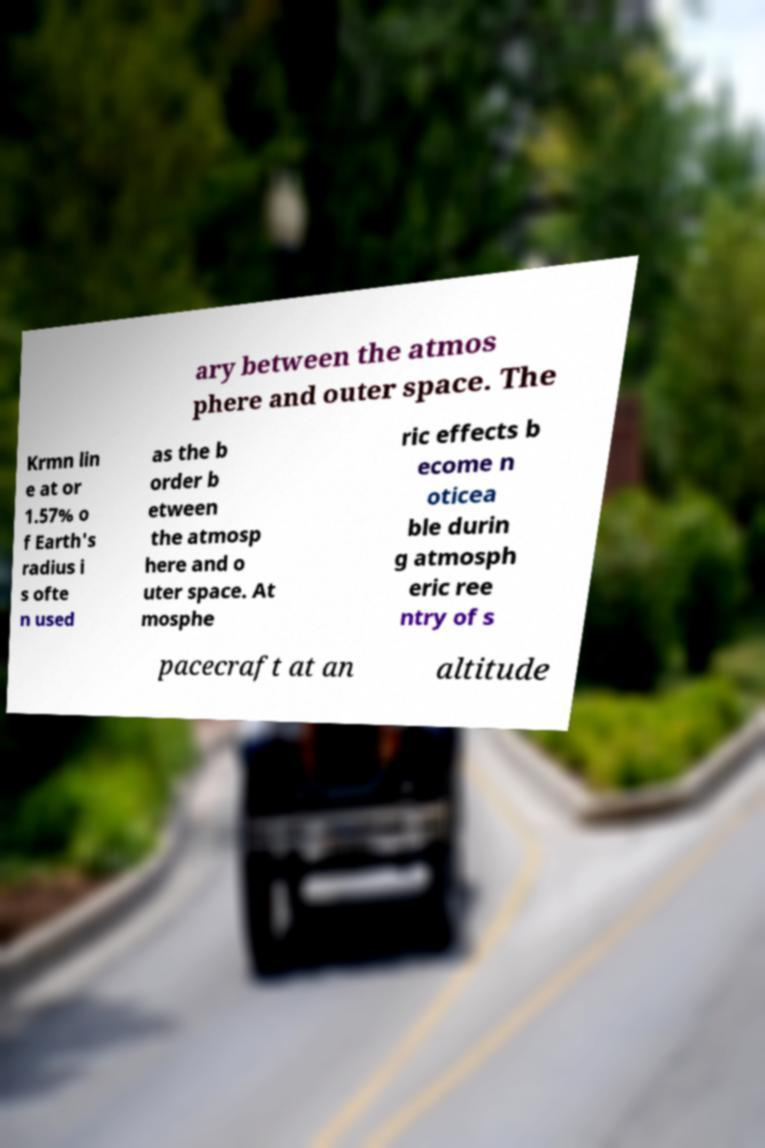For documentation purposes, I need the text within this image transcribed. Could you provide that? ary between the atmos phere and outer space. The Krmn lin e at or 1.57% o f Earth's radius i s ofte n used as the b order b etween the atmosp here and o uter space. At mosphe ric effects b ecome n oticea ble durin g atmosph eric ree ntry of s pacecraft at an altitude 